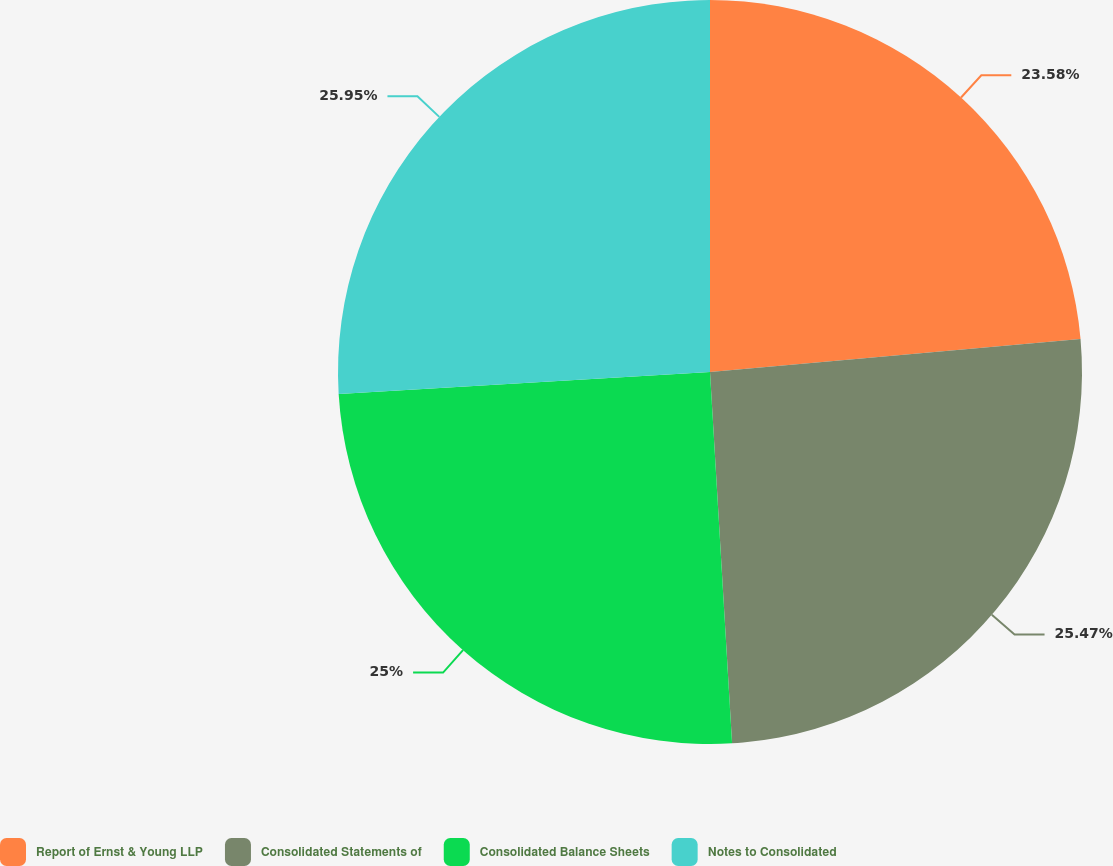Convert chart to OTSL. <chart><loc_0><loc_0><loc_500><loc_500><pie_chart><fcel>Report of Ernst & Young LLP<fcel>Consolidated Statements of<fcel>Consolidated Balance Sheets<fcel>Notes to Consolidated<nl><fcel>23.58%<fcel>25.47%<fcel>25.0%<fcel>25.94%<nl></chart> 